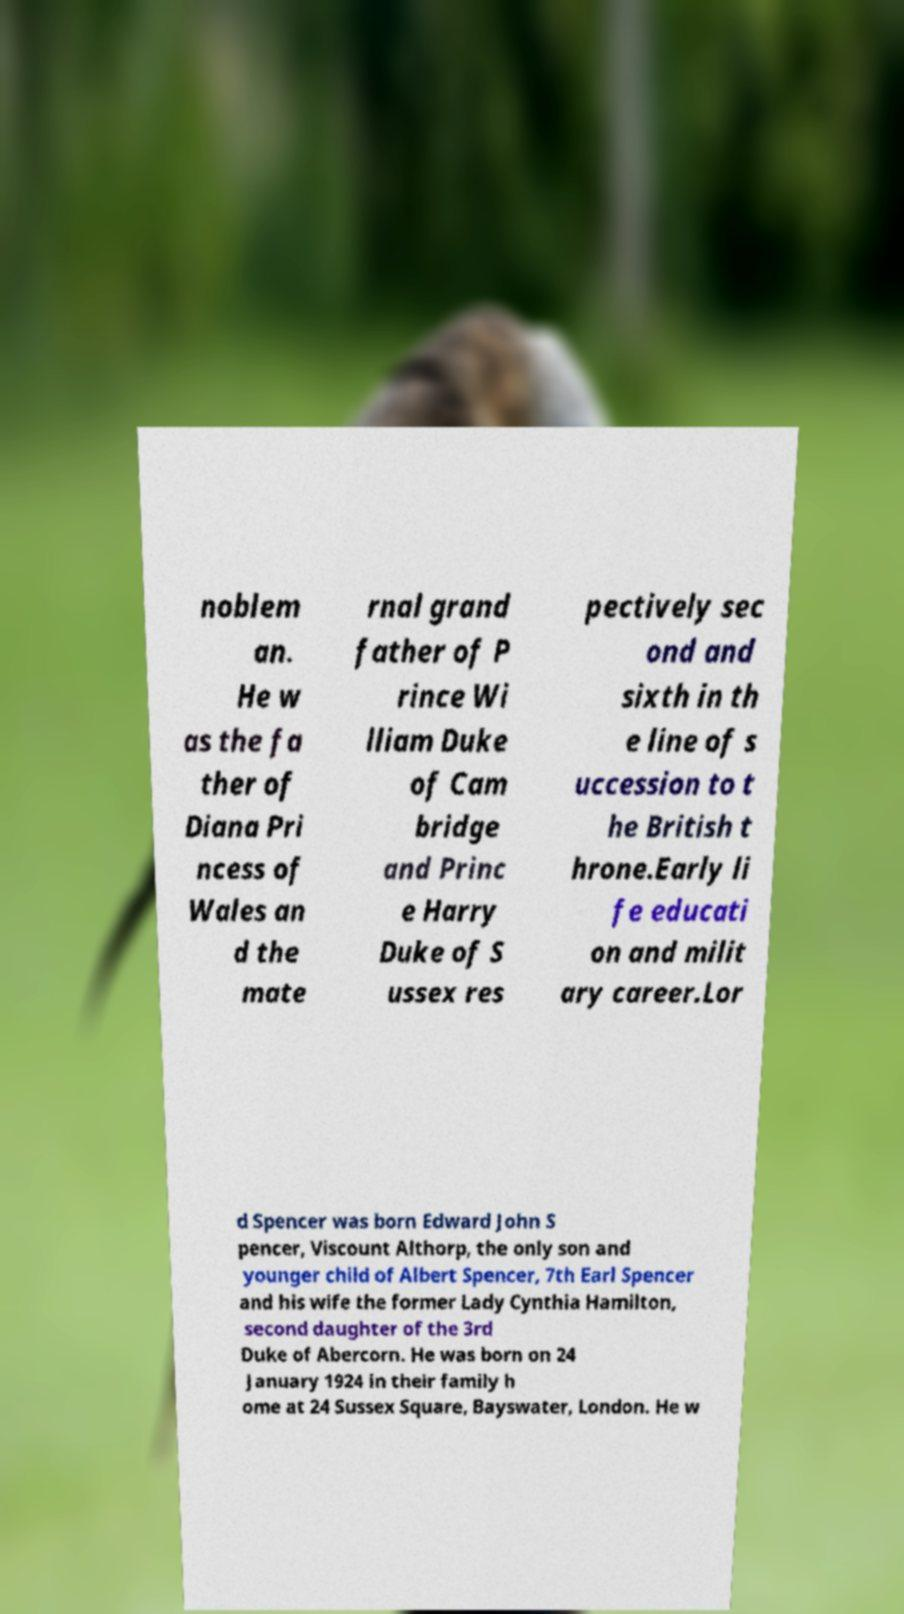Can you accurately transcribe the text from the provided image for me? noblem an. He w as the fa ther of Diana Pri ncess of Wales an d the mate rnal grand father of P rince Wi lliam Duke of Cam bridge and Princ e Harry Duke of S ussex res pectively sec ond and sixth in th e line of s uccession to t he British t hrone.Early li fe educati on and milit ary career.Lor d Spencer was born Edward John S pencer, Viscount Althorp, the only son and younger child of Albert Spencer, 7th Earl Spencer and his wife the former Lady Cynthia Hamilton, second daughter of the 3rd Duke of Abercorn. He was born on 24 January 1924 in their family h ome at 24 Sussex Square, Bayswater, London. He w 